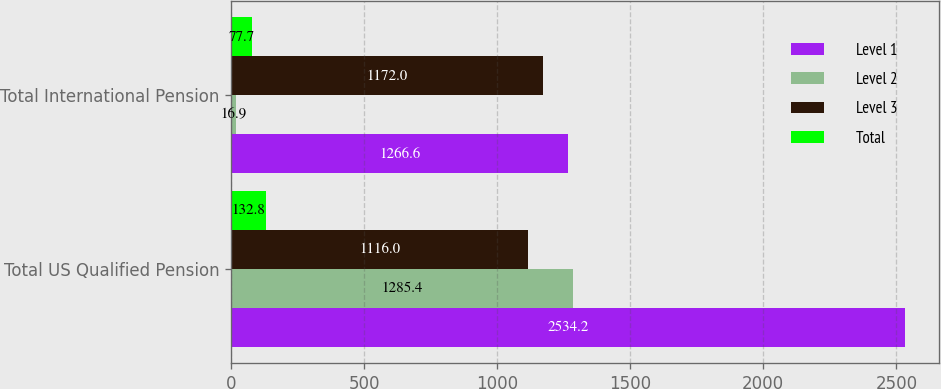Convert chart. <chart><loc_0><loc_0><loc_500><loc_500><stacked_bar_chart><ecel><fcel>Total US Qualified Pension<fcel>Total International Pension<nl><fcel>Level 1<fcel>2534.2<fcel>1266.6<nl><fcel>Level 2<fcel>1285.4<fcel>16.9<nl><fcel>Level 3<fcel>1116<fcel>1172<nl><fcel>Total<fcel>132.8<fcel>77.7<nl></chart> 